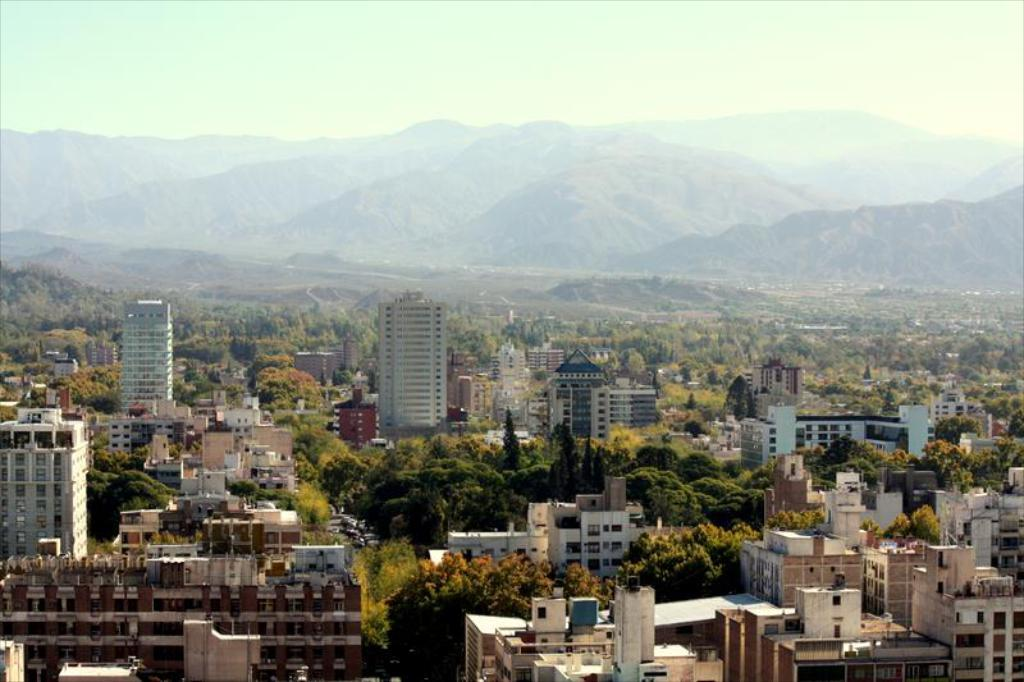What type of structures are present in the image? There are buildings with windows in the image. What natural elements can be seen in the image? There is a group of trees in the image. What can be seen in the distance in the image? Mountains are visible in the background of the image. What is visible above the buildings and trees in the image? The sky is visible in the background of the image. What is the taste of the sponge in the image? There is no sponge present in the image, so it is not possible to determine its taste. 